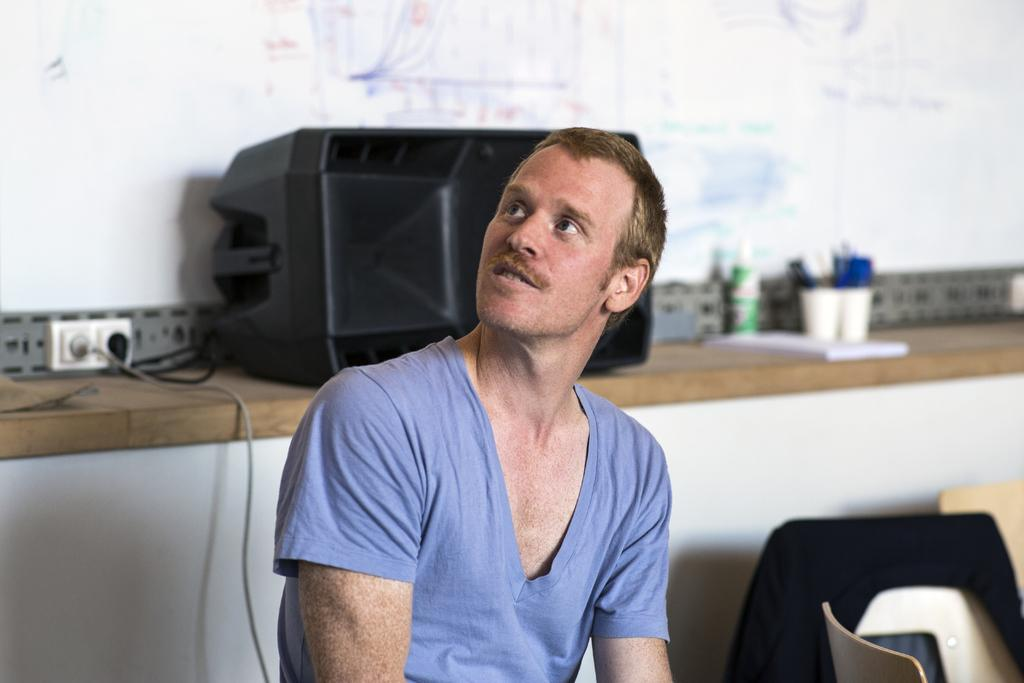What is the man in the image doing? The man is sitting in the image. What type of furniture is present in the image? There are chairs in the image. What can be seen behind the man? There is a device visible behind the man. Are there any cables in the image? Yes, cables are present in the image. What is the wooden platform holding in the image? There are objects on a wooden platform in the image. What is the background of the image? There is a wall in the image. What type of weather can be seen in the image? There is no weather visible in the image; it is an indoor setting. Can you tell me how many tramps are present in the image? There are no tramps present in the image. 